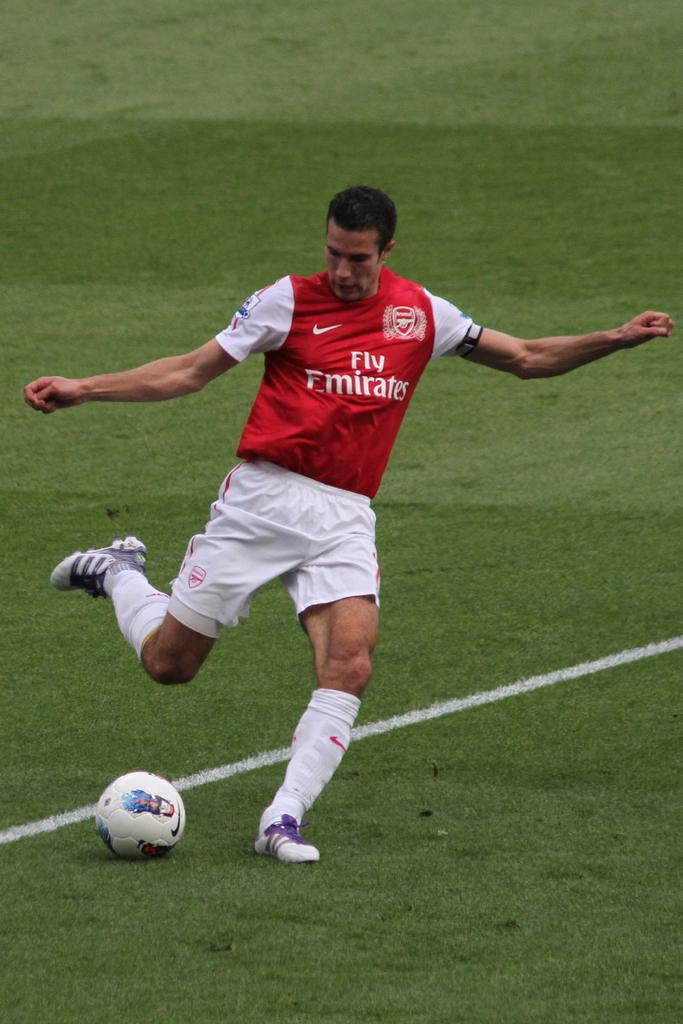What is the man in the image wearing? The man is wearing a jersey and shorts. What type of footwear is the man wearing? The man is wearing footwear in the image. What object can be seen in the image besides the man? There is a ball in the image. What type of surface is visible in the image? There is grass visible in the image. What marking can be seen on the ground in the image? There is a white line on the ground in the image. Are there any dinosaurs visible in the image? No, there are no dinosaurs present in the image. Is there a hose visible in the image? No, there is no hose present in the image. 